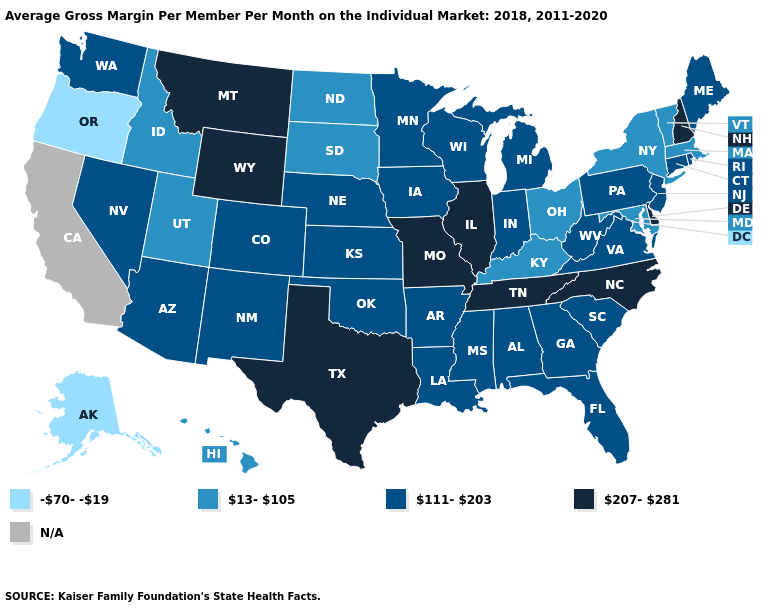What is the highest value in the USA?
Give a very brief answer. 207-281. What is the value of Wisconsin?
Answer briefly. 111-203. Name the states that have a value in the range -70--19?
Short answer required. Alaska, Oregon. What is the value of Montana?
Be succinct. 207-281. Does South Carolina have the lowest value in the USA?
Quick response, please. No. How many symbols are there in the legend?
Give a very brief answer. 5. What is the value of Minnesota?
Give a very brief answer. 111-203. Does Wisconsin have the lowest value in the USA?
Quick response, please. No. Name the states that have a value in the range N/A?
Give a very brief answer. California. Does Montana have the highest value in the West?
Give a very brief answer. Yes. Which states have the lowest value in the USA?
Write a very short answer. Alaska, Oregon. Which states have the highest value in the USA?
Keep it brief. Delaware, Illinois, Missouri, Montana, New Hampshire, North Carolina, Tennessee, Texas, Wyoming. Does Illinois have the highest value in the MidWest?
Keep it brief. Yes. Does Illinois have the highest value in the MidWest?
Write a very short answer. Yes. 